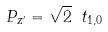<formula> <loc_0><loc_0><loc_500><loc_500>P _ { z ^ { \prime } } = \sqrt { 2 } \ t _ { 1 , 0 }</formula> 